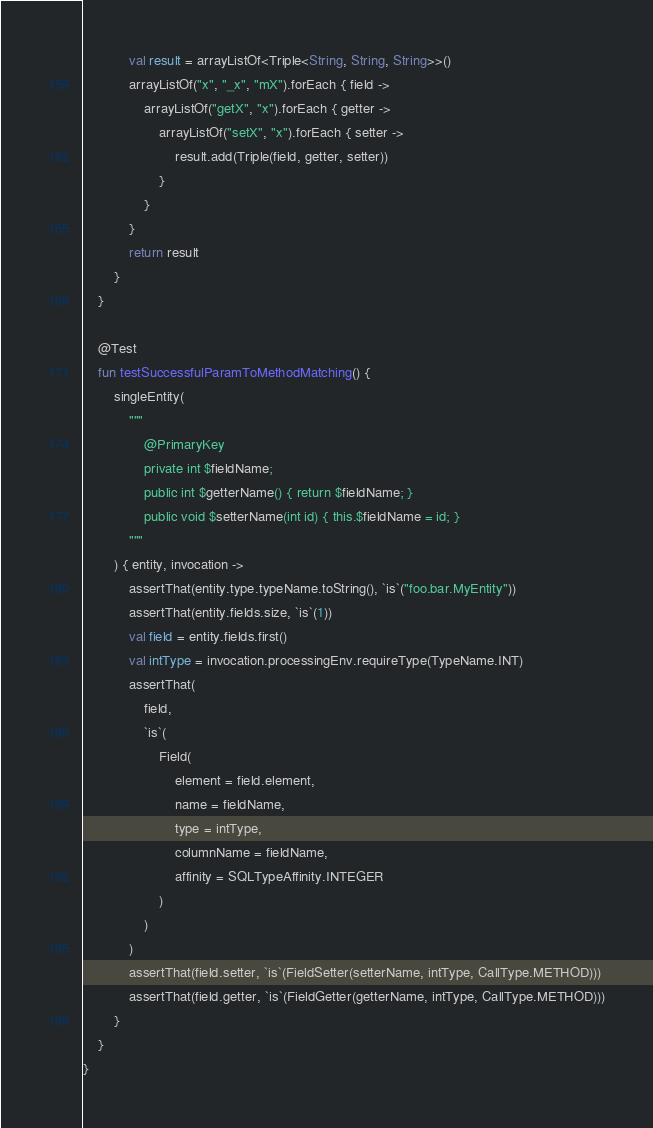Convert code to text. <code><loc_0><loc_0><loc_500><loc_500><_Kotlin_>            val result = arrayListOf<Triple<String, String, String>>()
            arrayListOf("x", "_x", "mX").forEach { field ->
                arrayListOf("getX", "x").forEach { getter ->
                    arrayListOf("setX", "x").forEach { setter ->
                        result.add(Triple(field, getter, setter))
                    }
                }
            }
            return result
        }
    }

    @Test
    fun testSuccessfulParamToMethodMatching() {
        singleEntity(
            """
                @PrimaryKey
                private int $fieldName;
                public int $getterName() { return $fieldName; }
                public void $setterName(int id) { this.$fieldName = id; }
            """
        ) { entity, invocation ->
            assertThat(entity.type.typeName.toString(), `is`("foo.bar.MyEntity"))
            assertThat(entity.fields.size, `is`(1))
            val field = entity.fields.first()
            val intType = invocation.processingEnv.requireType(TypeName.INT)
            assertThat(
                field,
                `is`(
                    Field(
                        element = field.element,
                        name = fieldName,
                        type = intType,
                        columnName = fieldName,
                        affinity = SQLTypeAffinity.INTEGER
                    )
                )
            )
            assertThat(field.setter, `is`(FieldSetter(setterName, intType, CallType.METHOD)))
            assertThat(field.getter, `is`(FieldGetter(getterName, intType, CallType.METHOD)))
        }
    }
}
</code> 